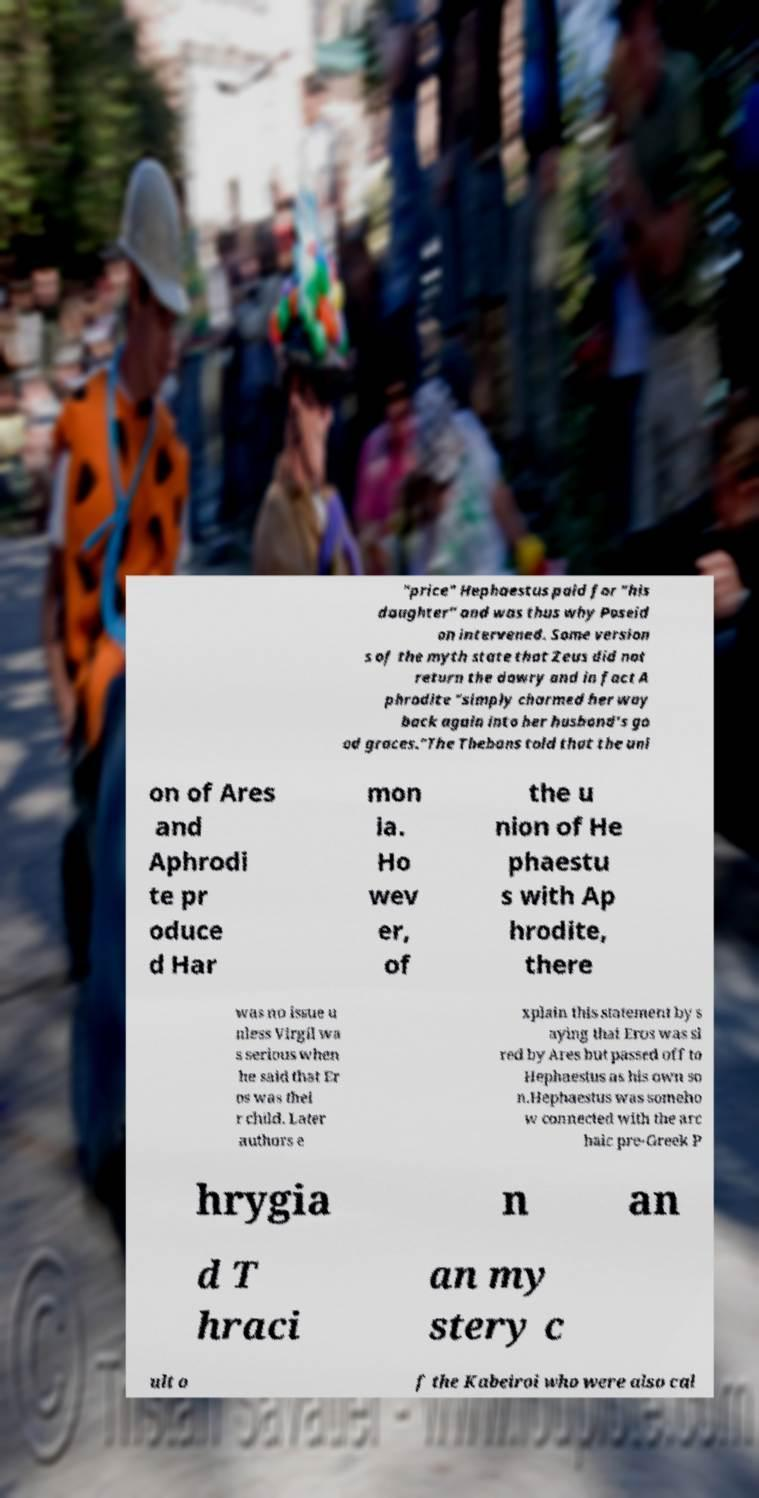What messages or text are displayed in this image? I need them in a readable, typed format. "price" Hephaestus paid for "his daughter" and was thus why Poseid on intervened. Some version s of the myth state that Zeus did not return the dowry and in fact A phrodite "simply charmed her way back again into her husband’s go od graces."The Thebans told that the uni on of Ares and Aphrodi te pr oduce d Har mon ia. Ho wev er, of the u nion of He phaestu s with Ap hrodite, there was no issue u nless Virgil wa s serious when he said that Er os was thei r child. Later authors e xplain this statement by s aying that Eros was si red by Ares but passed off to Hephaestus as his own so n.Hephaestus was someho w connected with the arc haic pre-Greek P hrygia n an d T hraci an my stery c ult o f the Kabeiroi who were also cal 